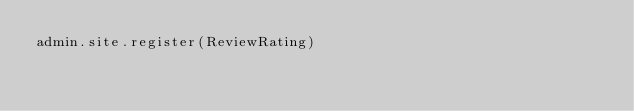Convert code to text. <code><loc_0><loc_0><loc_500><loc_500><_Python_>admin.site.register(ReviewRating)
</code> 